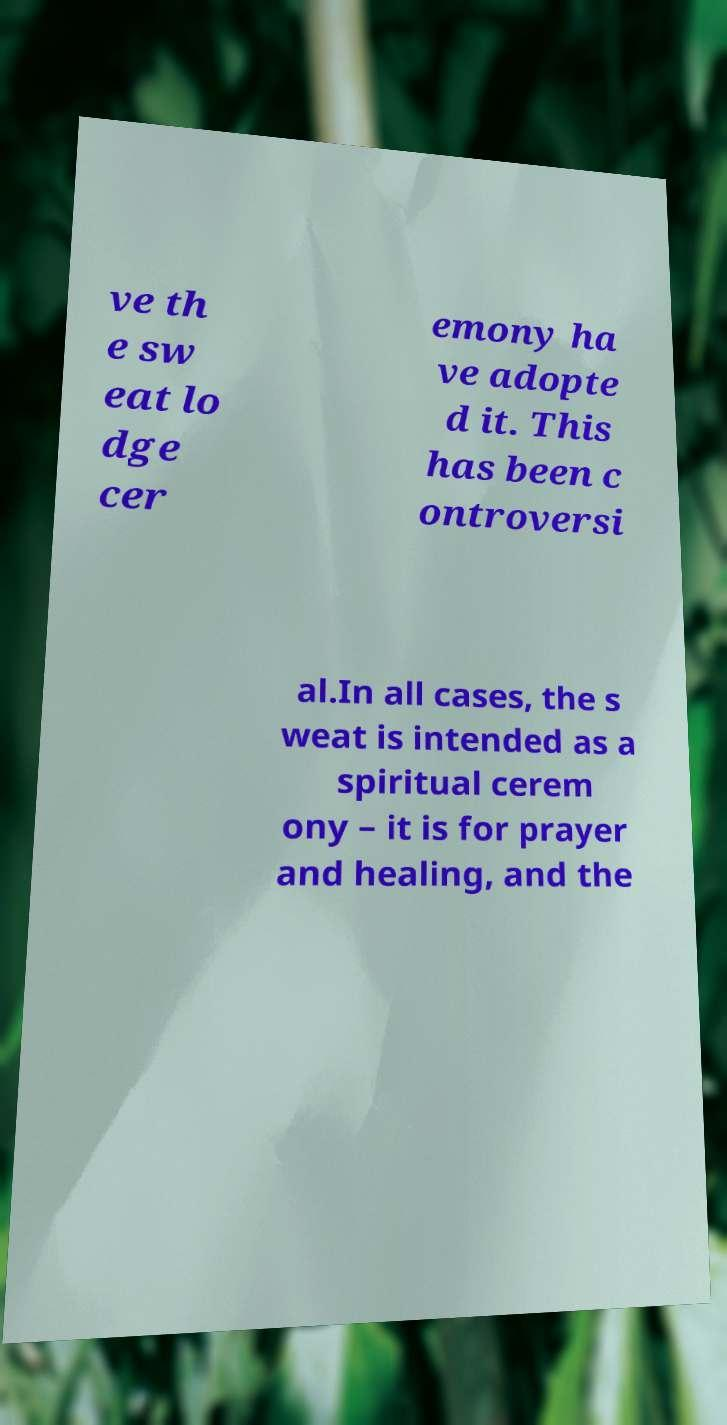For documentation purposes, I need the text within this image transcribed. Could you provide that? ve th e sw eat lo dge cer emony ha ve adopte d it. This has been c ontroversi al.In all cases, the s weat is intended as a spiritual cerem ony – it is for prayer and healing, and the 